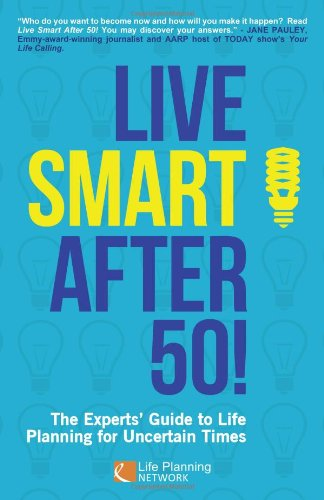What is the genre of this book? Judging by its content and title focusing on life planning, 'Live Smart After 50!' is primarily a Self-Help book. 